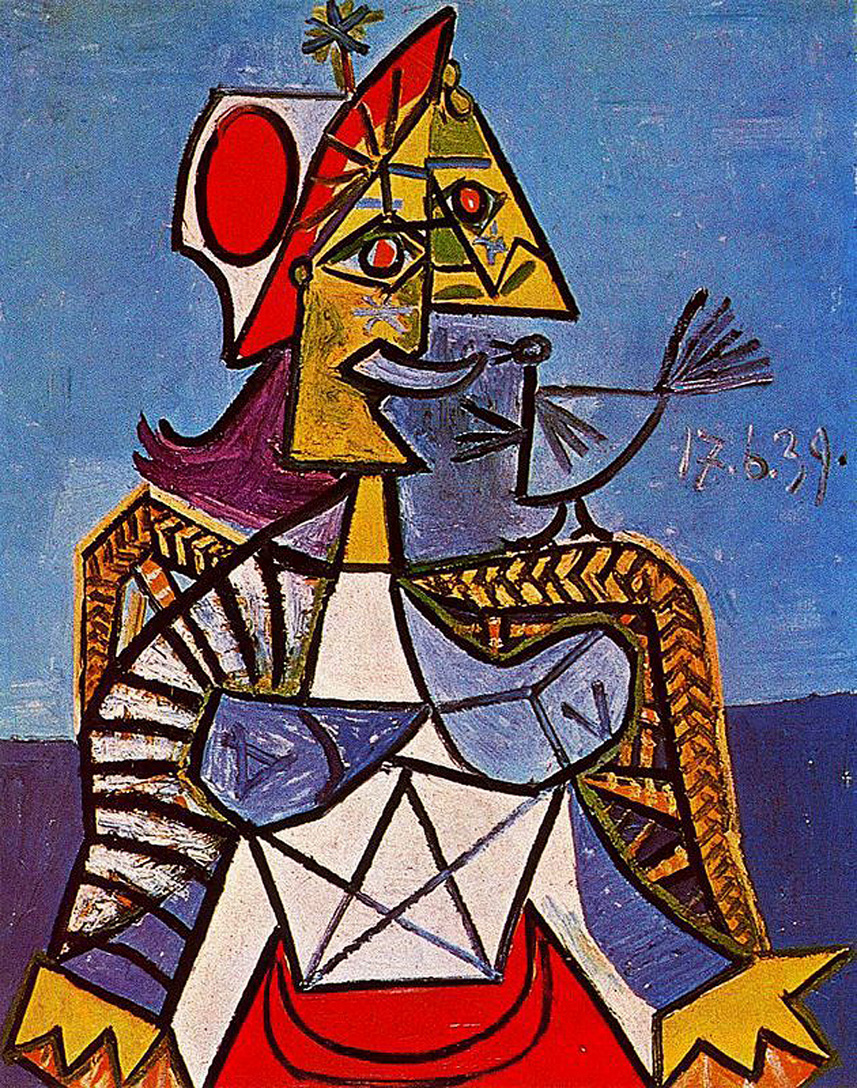Imagine this artwork is part of a story. What role does the crowned figure play in that story? In a story, the crowned figure in this artwork could be a wise and enigmatic ruler of a fantastical kingdom. Their kingdom is one where abstract and geometric forms truly come to life, representing different aspects of life and nature. The figure holds a unique bird, which is a magical creature capable of granting wishes or bringing peace to the land. The crown signifies their legitimate power, but also the weight of their responsibilities. In this narrative, the figure could be on a quest to balance abstract ideals with pragmatic realities, using their wisdom and the bird's mystical powers to unify their diverse and vibrant realm. 